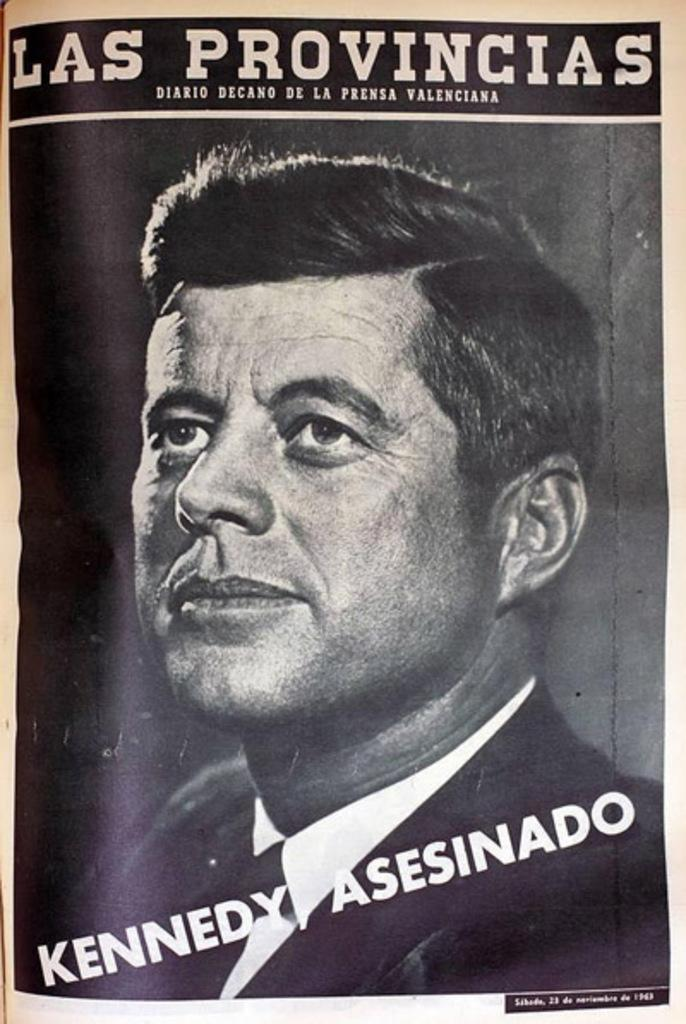<image>
Describe the image concisely. An ad in a foreign language about the Kennedy Assassination. 